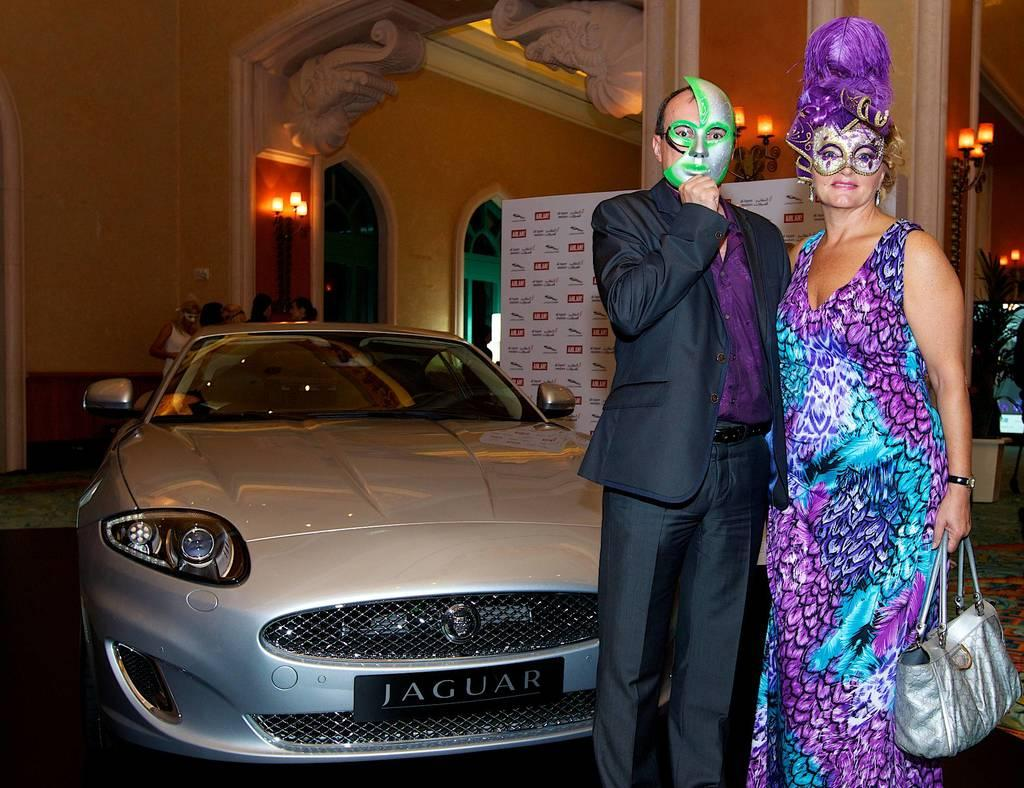How many people are present in the image? There are two people, a man and a woman, present in the image. What is the woman holding in the image? The woman is holding a bag. What are the man and woman wearing on their faces? Both the man and woman are wearing masks. What can be seen parked in the image? There is a car parked in the image. What type of structure is visible in the image? There is a building visible in the image. What type of rhythm can be heard coming from the boats in the image? There are no boats present in the image, so it is not possible to determine what rhythm might be heard. 